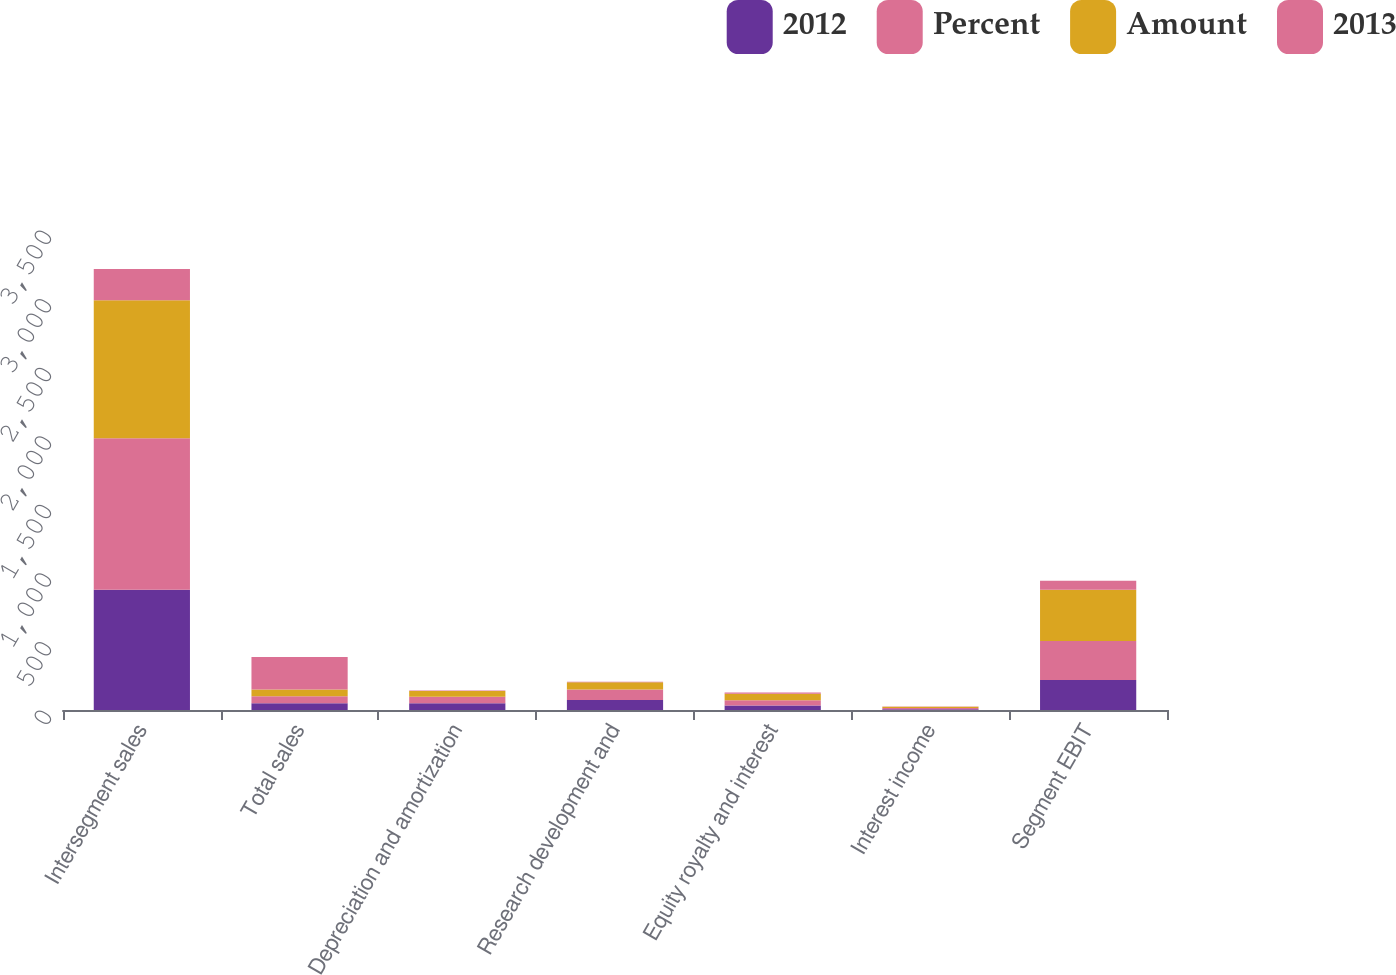Convert chart. <chart><loc_0><loc_0><loc_500><loc_500><stacked_bar_chart><ecel><fcel>Intersegment sales<fcel>Total sales<fcel>Depreciation and amortization<fcel>Research development and<fcel>Equity royalty and interest<fcel>Interest income<fcel>Segment EBIT<nl><fcel>2012<fcel>877<fcel>50<fcel>50<fcel>73<fcel>32<fcel>6<fcel>218<nl><fcel>Percent<fcel>1105<fcel>50<fcel>47<fcel>76<fcel>40<fcel>9<fcel>285<nl><fcel>Amount<fcel>1006<fcel>50<fcel>42<fcel>54<fcel>47<fcel>8<fcel>373<nl><fcel>2013<fcel>228<fcel>237<fcel>3<fcel>3<fcel>8<fcel>3<fcel>67<nl></chart> 